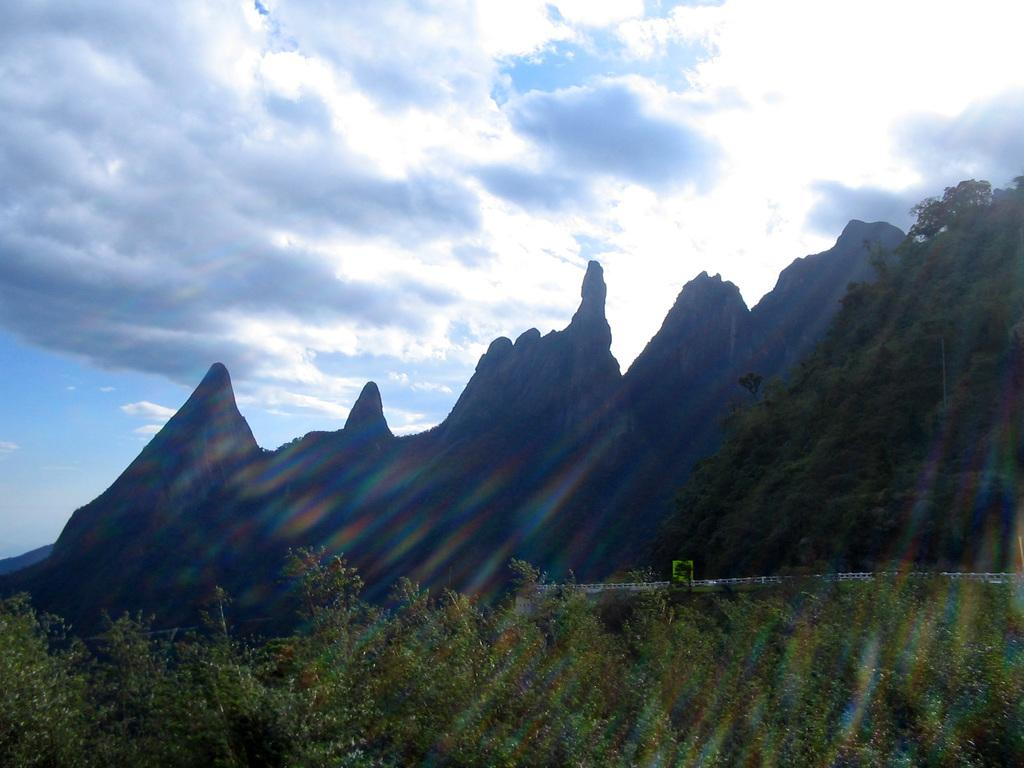What is in the foreground of the picture? There are trees in the foreground of the picture. What can be seen in the center of the picture? There are trees and a mountain in the center of the picture. What is visible in the background of the image? The sky is visible in the image. How would you describe the weather in the image? The sky is partly cloudy, and the sun is shining, suggesting a partly cloudy day. Can you see a hole in the mountain in the image? There is no hole visible in the mountain in the image. What type of paste is being used to paint the trees in the image? There is no indication that any painting or paste is involved in the image; it is a natural scene with trees, a mountain, and the sky. 